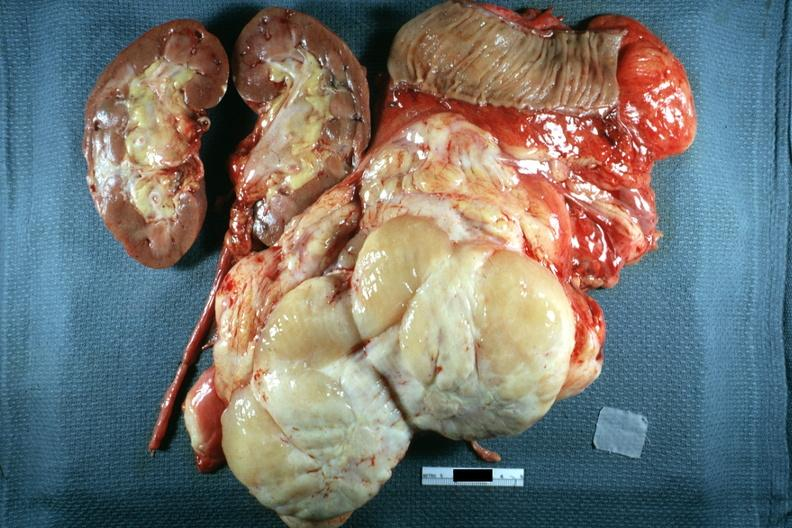s this section showing liver with tumor mass in hilar area tumor present?
Answer the question using a single word or phrase. No 